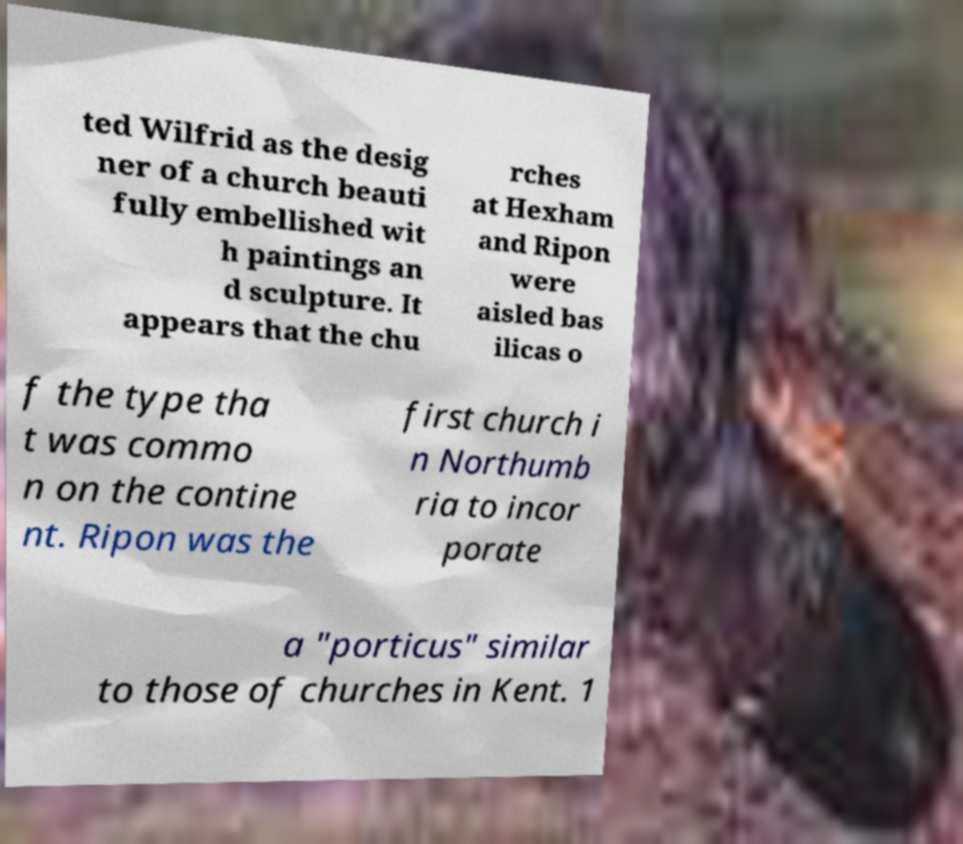Can you accurately transcribe the text from the provided image for me? ted Wilfrid as the desig ner of a church beauti fully embellished wit h paintings an d sculpture. It appears that the chu rches at Hexham and Ripon were aisled bas ilicas o f the type tha t was commo n on the contine nt. Ripon was the first church i n Northumb ria to incor porate a "porticus" similar to those of churches in Kent. 1 